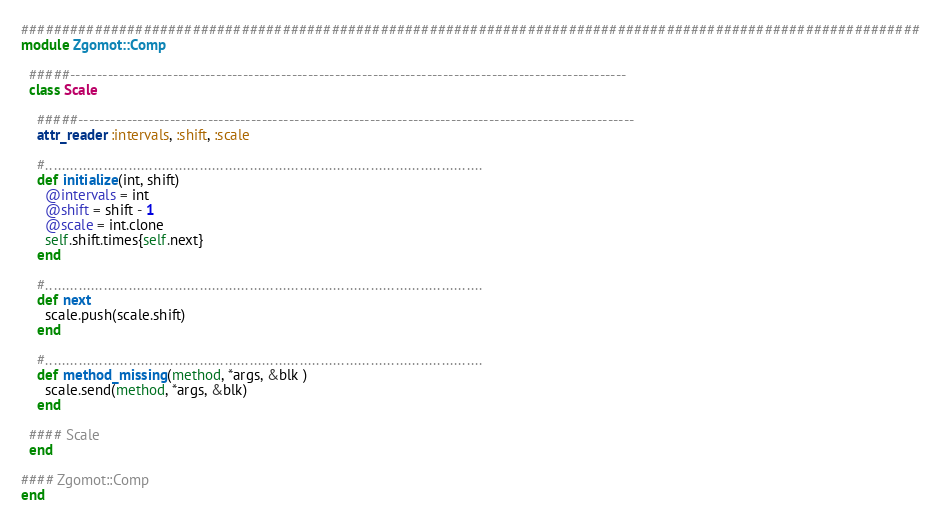Convert code to text. <code><loc_0><loc_0><loc_500><loc_500><_Ruby_>##############################################################################################################
module Zgomot::Comp

  #####-------------------------------------------------------------------------------------------------------
  class Scale
    
    #####-------------------------------------------------------------------------------------------------------
    attr_reader :intervals, :shift, :scale
  
    #.........................................................................................................
    def initialize(int, shift)
      @intervals = int
      @shift = shift - 1
      @scale = int.clone
      self.shift.times{self.next}
    end

    #.........................................................................................................
    def next
      scale.push(scale.shift) 
    end
    
    #.........................................................................................................
    def method_missing(method, *args, &blk )
      scale.send(method, *args, &blk)
    end
      
  #### Scale
  end

#### Zgomot::Comp 
end
</code> 